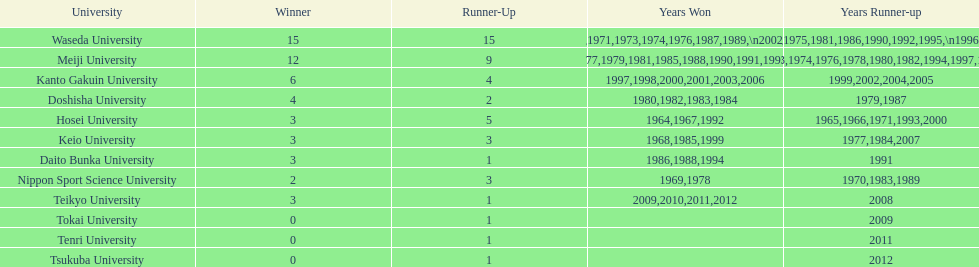Help me parse the entirety of this table. {'header': ['University', 'Winner', 'Runner-Up', 'Years Won', 'Years Runner-up'], 'rows': [['Waseda University', '15', '15', '1965,1966,1968,1970,1971,1973,1974,1976,1987,1989,\\n2002,2004,2005,2007,2008', '1964,1967,1969,1972,1975,1981,1986,1990,1992,1995,\\n1996,2001,2003,2006,2010'], ['Meiji University', '12', '9', '1972,1975,1977,1979,1981,1985,1988,1990,1991,1993,\\n1995,1996', '1973,1974,1976,1978,1980,1982,1994,1997,1998'], ['Kanto Gakuin University', '6', '4', '1997,1998,2000,2001,2003,2006', '1999,2002,2004,2005'], ['Doshisha University', '4', '2', '1980,1982,1983,1984', '1979,1987'], ['Hosei University', '3', '5', '1964,1967,1992', '1965,1966,1971,1993,2000'], ['Keio University', '3', '3', '1968,1985,1999', '1977,1984,2007'], ['Daito Bunka University', '3', '1', '1986,1988,1994', '1991'], ['Nippon Sport Science University', '2', '3', '1969,1978', '1970,1983,1989'], ['Teikyo University', '3', '1', '2009,2010,2011,2012', '2008'], ['Tokai University', '0', '1', '', '2009'], ['Tenri University', '0', '1', '', '2011'], ['Tsukuba University', '0', '1', '', '2012']]} After hosei's 1964 victory, who claimed the win in 1965? Waseda University. 